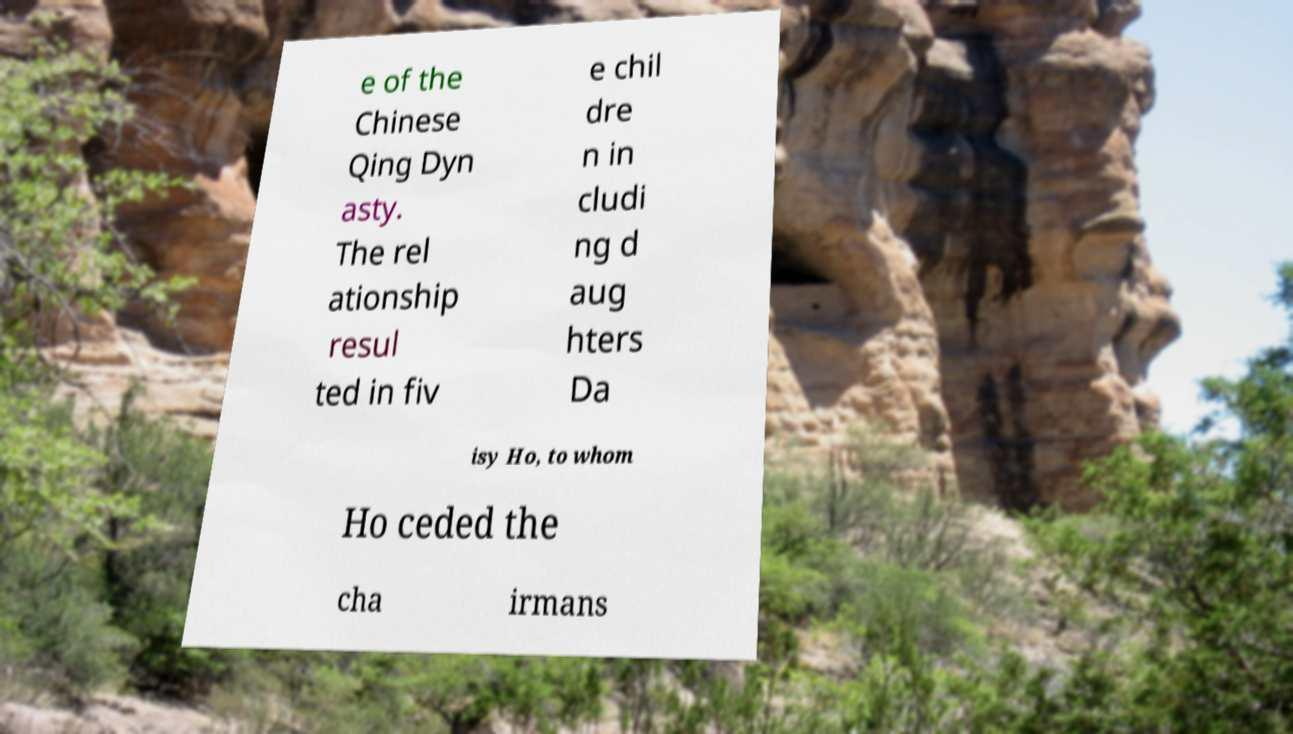Can you read and provide the text displayed in the image?This photo seems to have some interesting text. Can you extract and type it out for me? e of the Chinese Qing Dyn asty. The rel ationship resul ted in fiv e chil dre n in cludi ng d aug hters Da isy Ho, to whom Ho ceded the cha irmans 